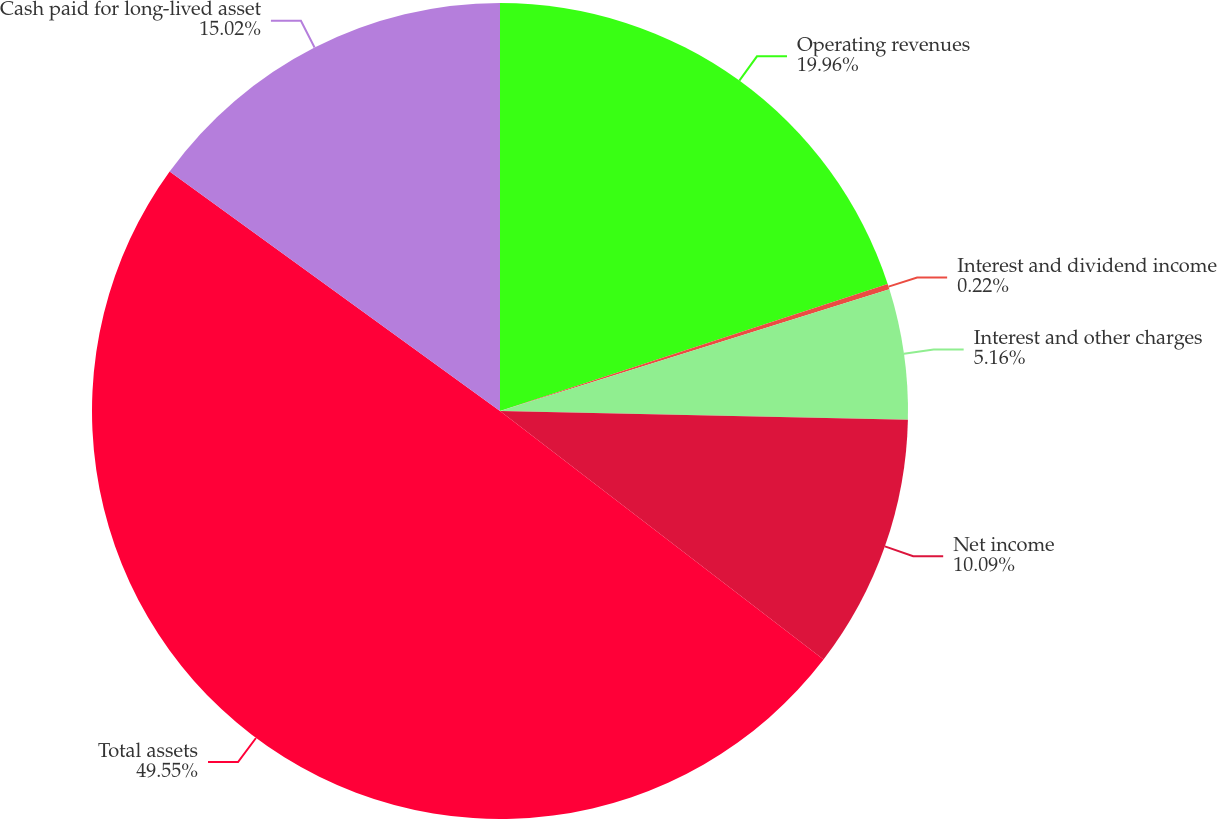<chart> <loc_0><loc_0><loc_500><loc_500><pie_chart><fcel>Operating revenues<fcel>Interest and dividend income<fcel>Interest and other charges<fcel>Net income<fcel>Total assets<fcel>Cash paid for long-lived asset<nl><fcel>19.96%<fcel>0.22%<fcel>5.16%<fcel>10.09%<fcel>49.56%<fcel>15.02%<nl></chart> 